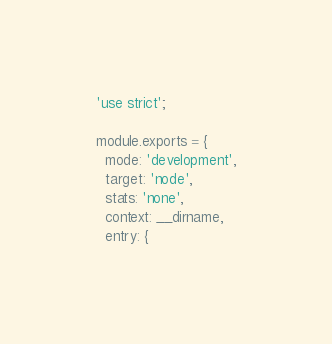Convert code to text. <code><loc_0><loc_0><loc_500><loc_500><_JavaScript_>'use strict';

module.exports = {
  mode: 'development',
  target: 'node',
  stats: 'none',
  context: __dirname,
  entry: {</code> 